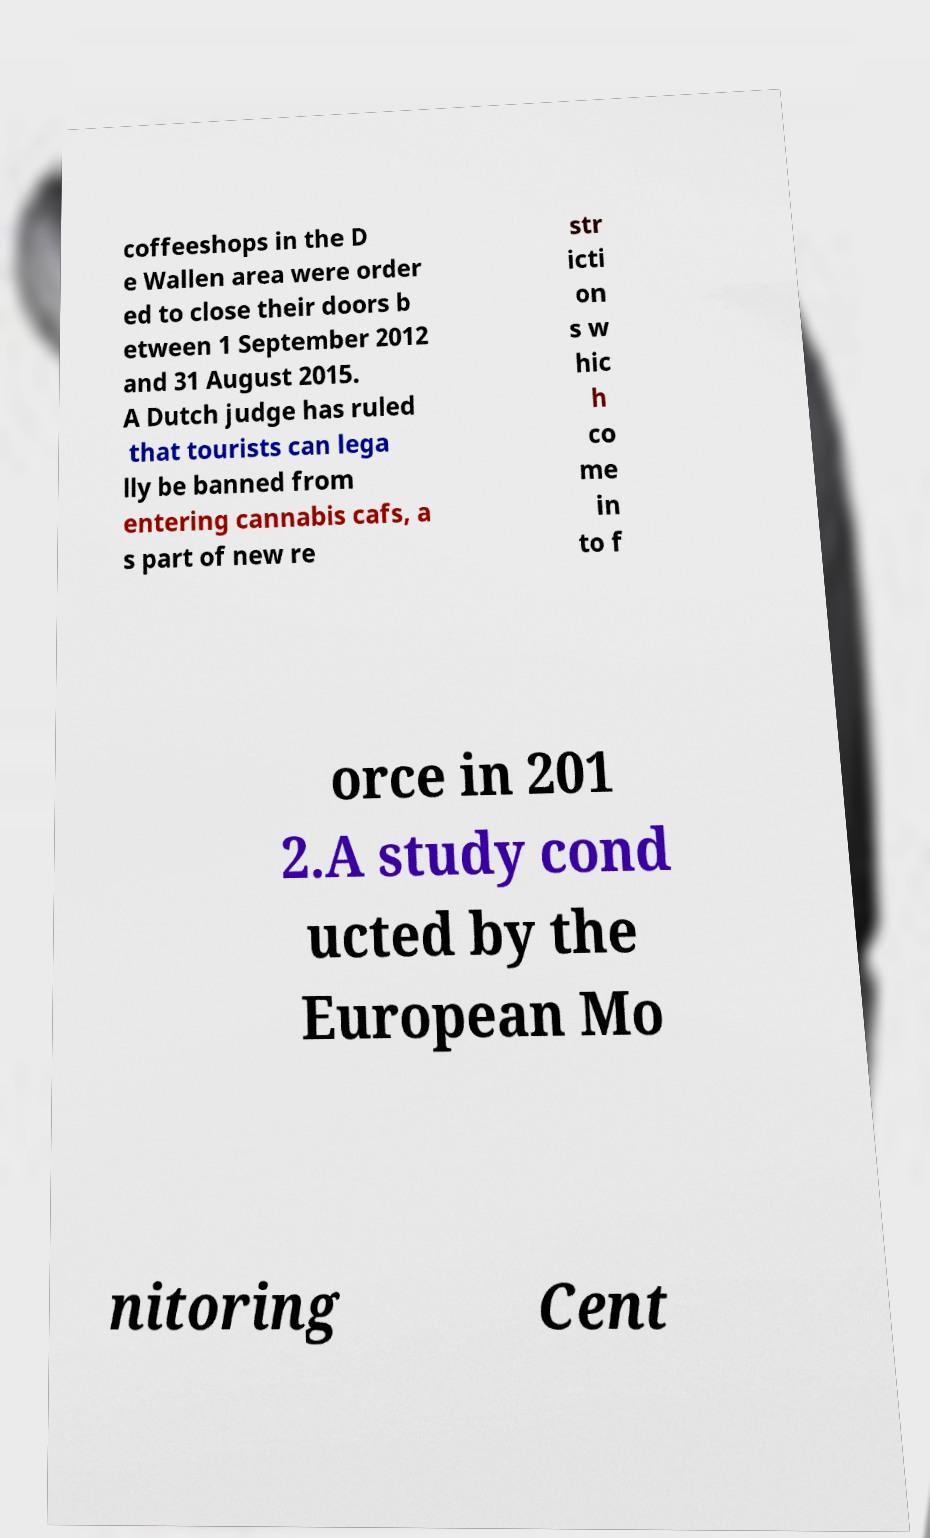Can you read and provide the text displayed in the image?This photo seems to have some interesting text. Can you extract and type it out for me? coffeeshops in the D e Wallen area were order ed to close their doors b etween 1 September 2012 and 31 August 2015. A Dutch judge has ruled that tourists can lega lly be banned from entering cannabis cafs, a s part of new re str icti on s w hic h co me in to f orce in 201 2.A study cond ucted by the European Mo nitoring Cent 